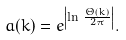Convert formula to latex. <formula><loc_0><loc_0><loc_500><loc_500>a ( k ) = e ^ { \left | \ln \, \frac { \Theta ( k ) } { 2 \pi } \right | } .</formula> 